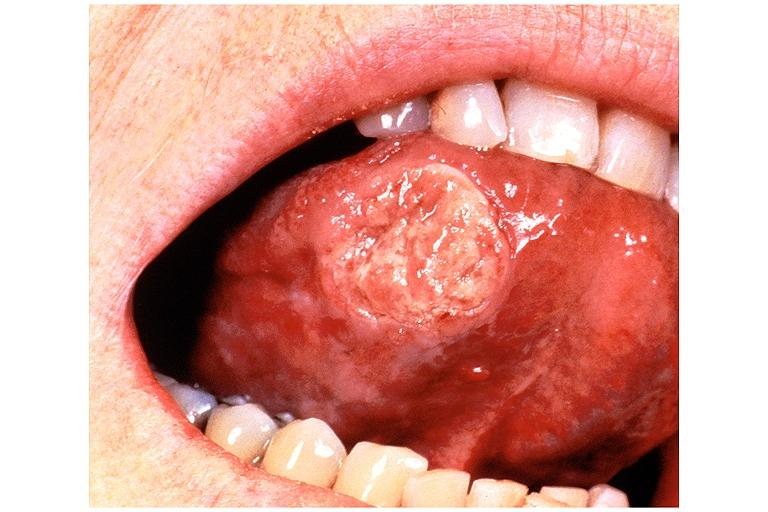s vasculitis due to rocky mountain present?
Answer the question using a single word or phrase. No 